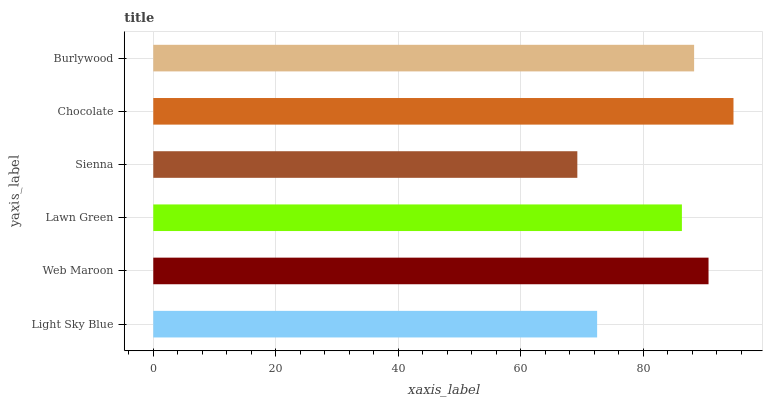Is Sienna the minimum?
Answer yes or no. Yes. Is Chocolate the maximum?
Answer yes or no. Yes. Is Web Maroon the minimum?
Answer yes or no. No. Is Web Maroon the maximum?
Answer yes or no. No. Is Web Maroon greater than Light Sky Blue?
Answer yes or no. Yes. Is Light Sky Blue less than Web Maroon?
Answer yes or no. Yes. Is Light Sky Blue greater than Web Maroon?
Answer yes or no. No. Is Web Maroon less than Light Sky Blue?
Answer yes or no. No. Is Burlywood the high median?
Answer yes or no. Yes. Is Lawn Green the low median?
Answer yes or no. Yes. Is Web Maroon the high median?
Answer yes or no. No. Is Light Sky Blue the low median?
Answer yes or no. No. 